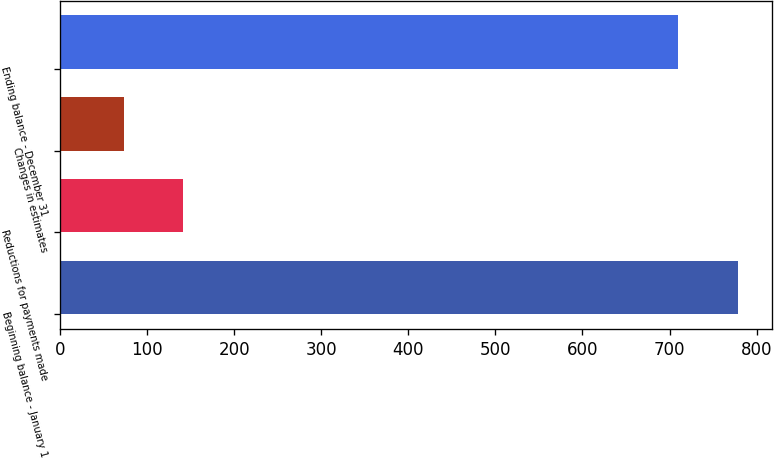Convert chart to OTSL. <chart><loc_0><loc_0><loc_500><loc_500><bar_chart><fcel>Beginning balance - January 1<fcel>Reductions for payments made<fcel>Changes in estimates<fcel>Ending balance - December 31<nl><fcel>778.5<fcel>141.5<fcel>73<fcel>710<nl></chart> 